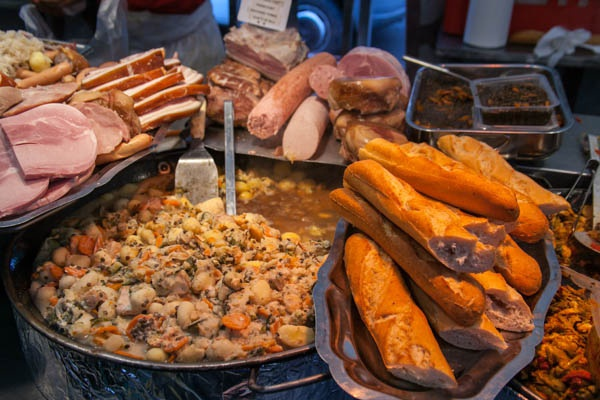Describe the objects in this image and their specific colors. I can see bowl in black, brown, tan, and maroon tones, hot dog in black, red, brown, and orange tones, hot dog in black, brown, red, orange, and maroon tones, hot dog in black, red, brown, orange, and maroon tones, and people in black, gray, and darkblue tones in this image. 